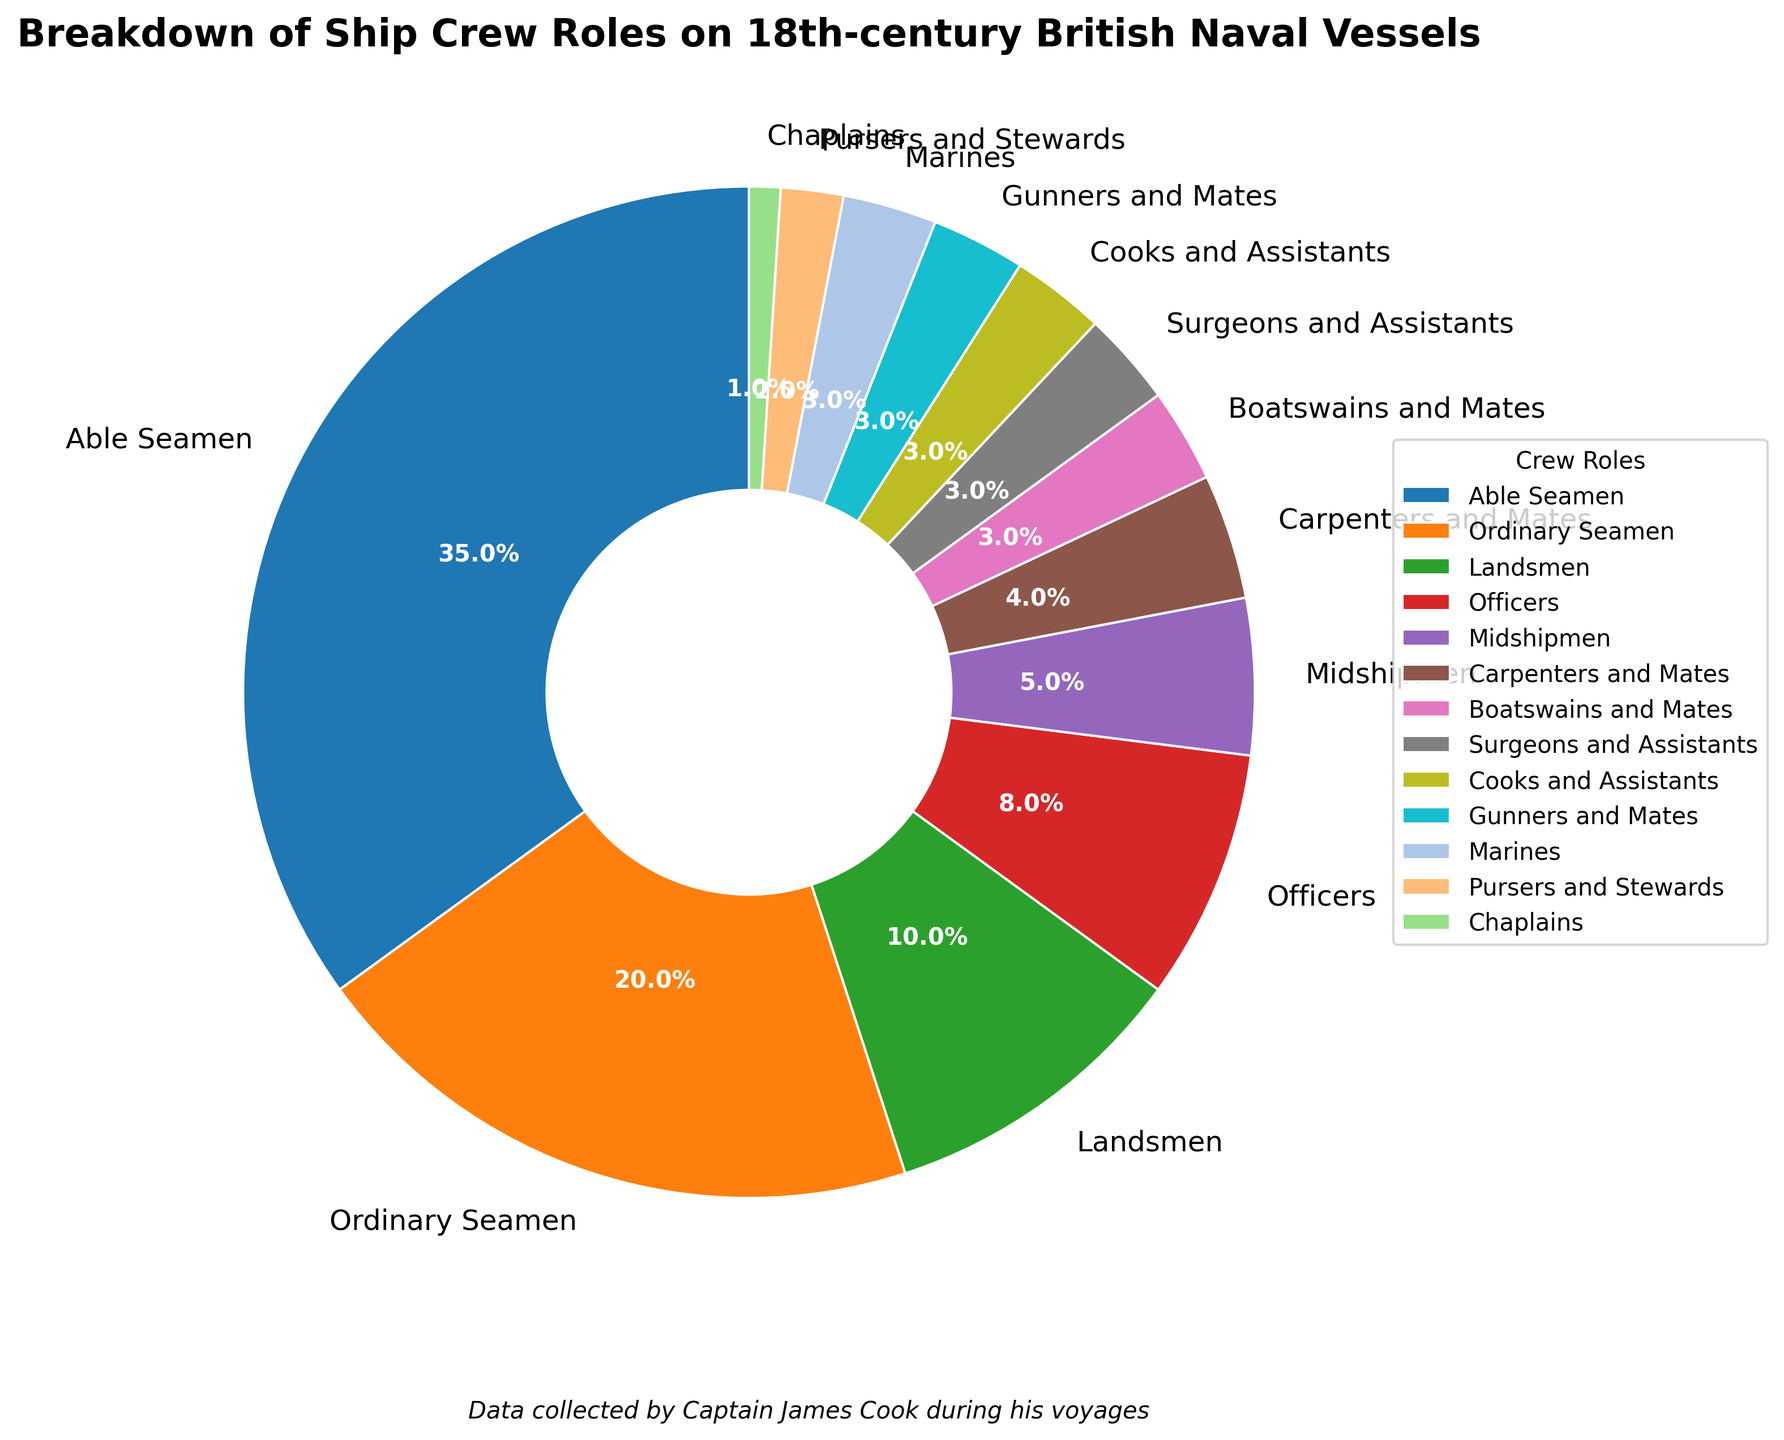What percentage of the ship’s crew are either Able Seamen or Ordinary Seamen? To calculate the combined percentage of Able Seamen and Ordinary Seamen, add their individual percentages: 35% (Able Seamen) + 20% (Ordinary Seamen) = 55%.
Answer: 55% Which crew role has the smallest percentage, and what is it? By looking at the pie chart, the role with the smallest segment or the smallest percentage is the Chaplains role with 1%.
Answer: Chaplains, 1% Are there more Able Seamen or a combined total of Officers and Midshipmen? Combine the percentages of Officers and Midshipmen: 8% (Officers) + 5% (Midshipmen) = 13%. Compare this with 35% (Able Seamen). Since 35% > 13%, there are more Able Seamen.
Answer: Able Seamen What is the difference between the percentage of Able Seamen and Landsmen? Subtract the percentage of Landsmen from the percentage of Able Seamen: 35% (Able Seamen) - 10% (Landsmen) = 25%.
Answer: 25% Which crew roles comprise exactly 3% each? Looking at the pie chart, the roles that each account for 3% are Boatswains and Mates, Surgeons and Assistants, Cooks and Assistants, Gunners and Mates, and Marines.
Answer: Boatswains and Mates, Surgeons and Assistants, Cooks and Assistants, Gunners and Mates, Marines How many roles have percentages below 5%? By examining the pie chart segments with percentages below 5%: Carpenters and Mates (4%), Boatswains and Mates (3%), Surgeons and Assistants (3%), Cooks and Assistants (3%), Gunners and Mates (3%), Marines (3%), Pursers and Stewards (2%), and Chaplains (1%). There are 8 roles in total.
Answer: 8 What is the combined percentage of the support staff roles (Carpenters and Mates, Boatswains and Mates, Surgeons and Assistants, Cooks and Assistants, Pursers and Stewards, Chaplains)? Add the individual percentages of the support staff roles: 4% + 3% + 3% + 3% + 2% + 1% = 16%.
Answer: 16% How does the percentage of Midshipmen compare to that of Officers? Midshipmen account for 5% while Officers account for 8%. Since 5% < 8%, there are fewer Midshipmen than Officers.
Answer: Fewer Midshipmen than Officers Compare the percentages of the roles "Surgeons and Assistants" and "Cooks and Assistants." Both "Surgeons and Assistants" and "Cooks and Assistants" each account for 3% of the crew. Therefore, they are equal.
Answer: Equal 